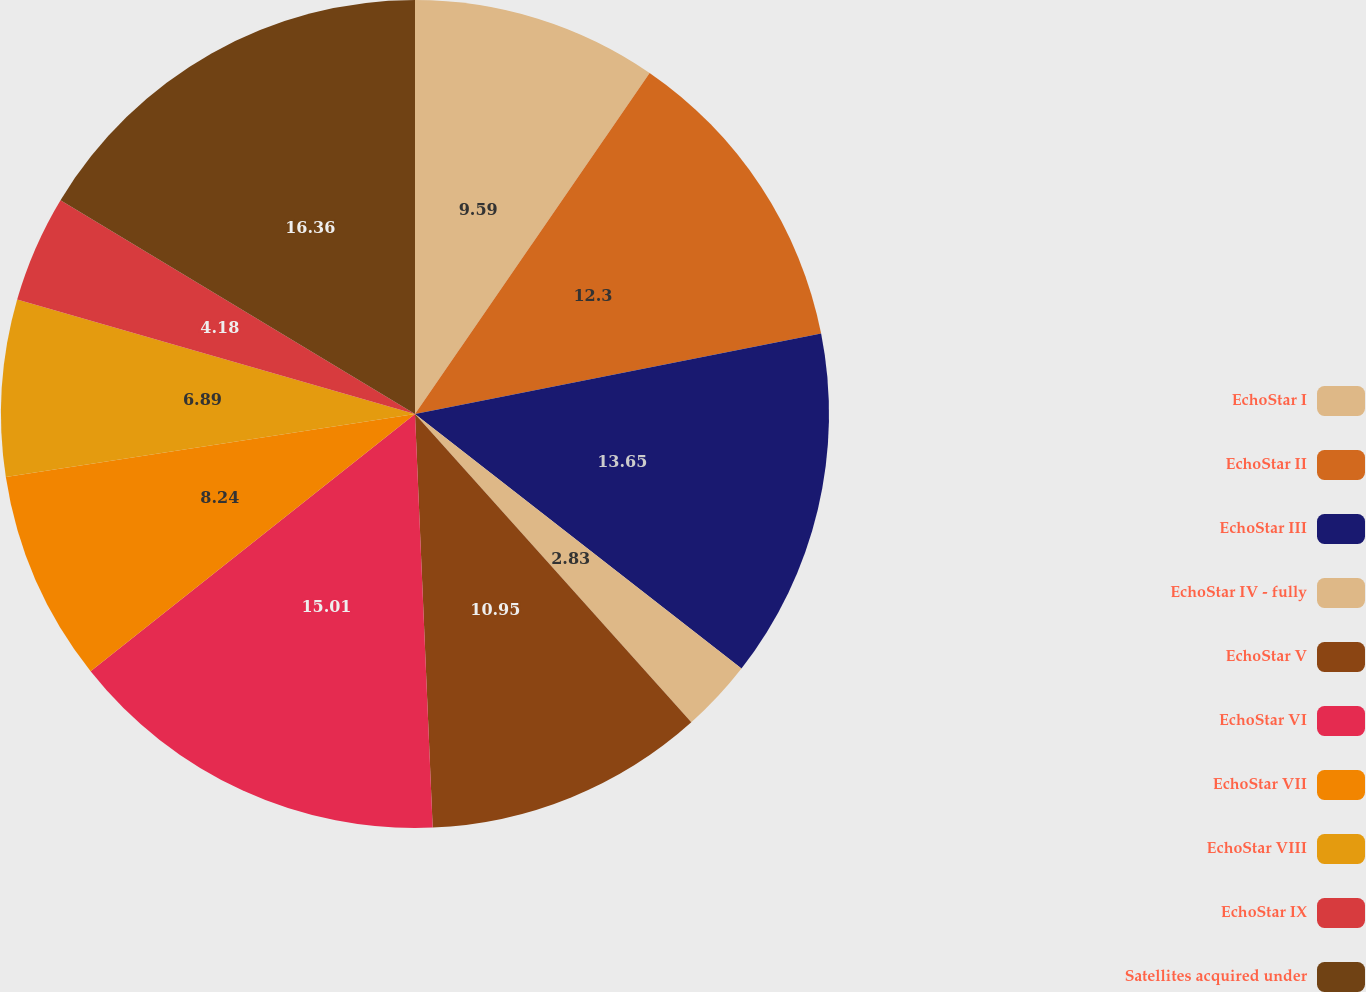Convert chart to OTSL. <chart><loc_0><loc_0><loc_500><loc_500><pie_chart><fcel>EchoStar I<fcel>EchoStar II<fcel>EchoStar III<fcel>EchoStar IV - fully<fcel>EchoStar V<fcel>EchoStar VI<fcel>EchoStar VII<fcel>EchoStar VIII<fcel>EchoStar IX<fcel>Satellites acquired under<nl><fcel>9.59%<fcel>12.3%<fcel>13.65%<fcel>2.83%<fcel>10.95%<fcel>15.01%<fcel>8.24%<fcel>6.89%<fcel>4.18%<fcel>16.36%<nl></chart> 